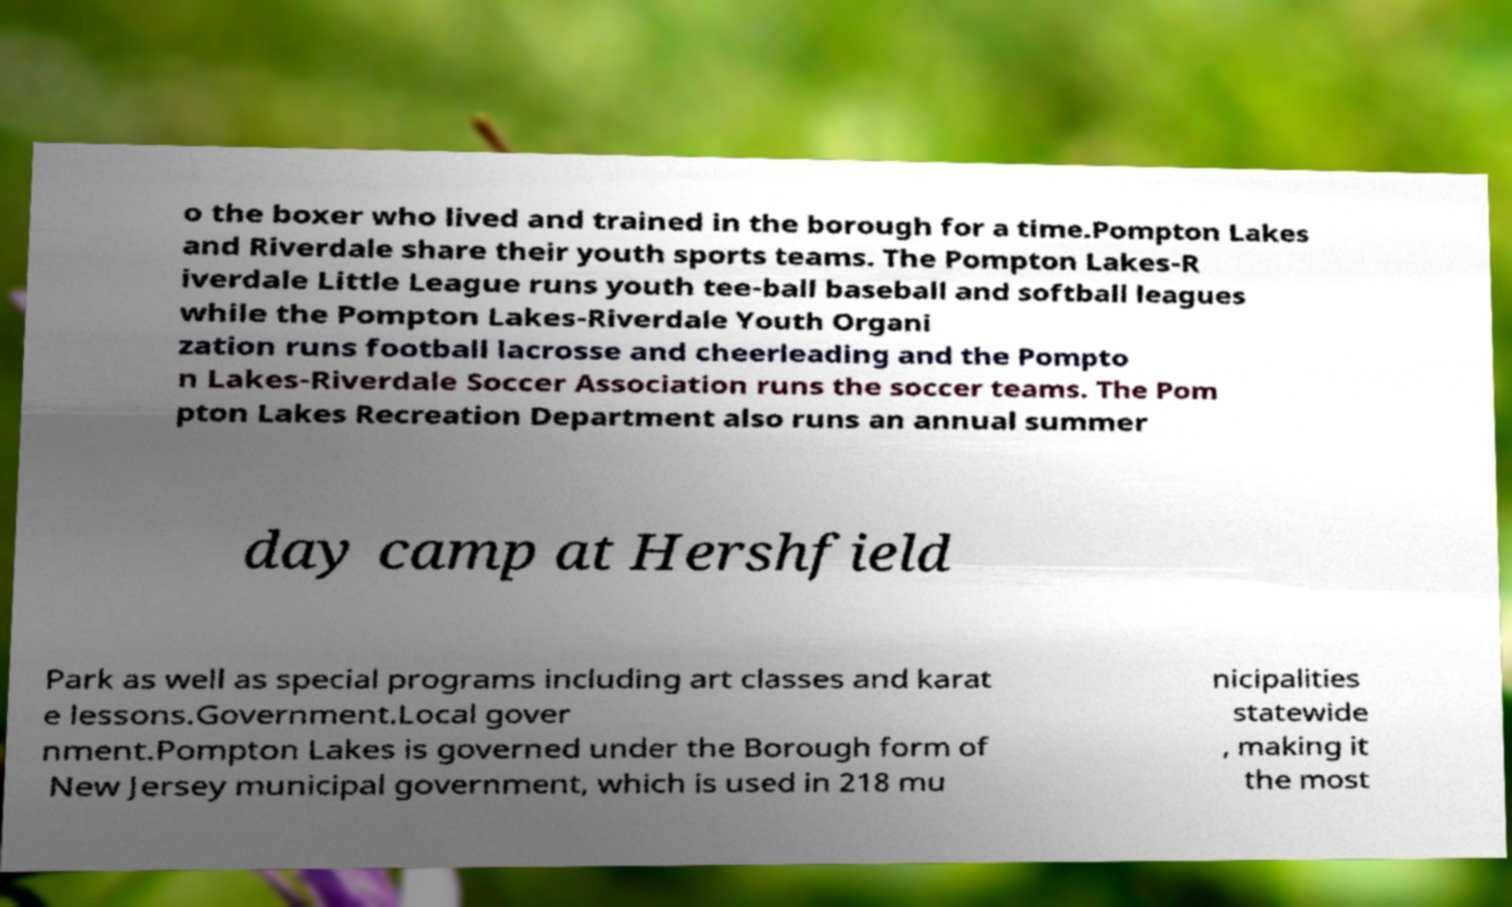What messages or text are displayed in this image? I need them in a readable, typed format. o the boxer who lived and trained in the borough for a time.Pompton Lakes and Riverdale share their youth sports teams. The Pompton Lakes-R iverdale Little League runs youth tee-ball baseball and softball leagues while the Pompton Lakes-Riverdale Youth Organi zation runs football lacrosse and cheerleading and the Pompto n Lakes-Riverdale Soccer Association runs the soccer teams. The Pom pton Lakes Recreation Department also runs an annual summer day camp at Hershfield Park as well as special programs including art classes and karat e lessons.Government.Local gover nment.Pompton Lakes is governed under the Borough form of New Jersey municipal government, which is used in 218 mu nicipalities statewide , making it the most 